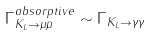Convert formula to latex. <formula><loc_0><loc_0><loc_500><loc_500>\Gamma _ { K _ { L } \rightarrow \mu \bar { \mu } } ^ { a b s o r p t i v e } \sim \Gamma _ { K _ { L } \rightarrow \gamma \gamma }</formula> 